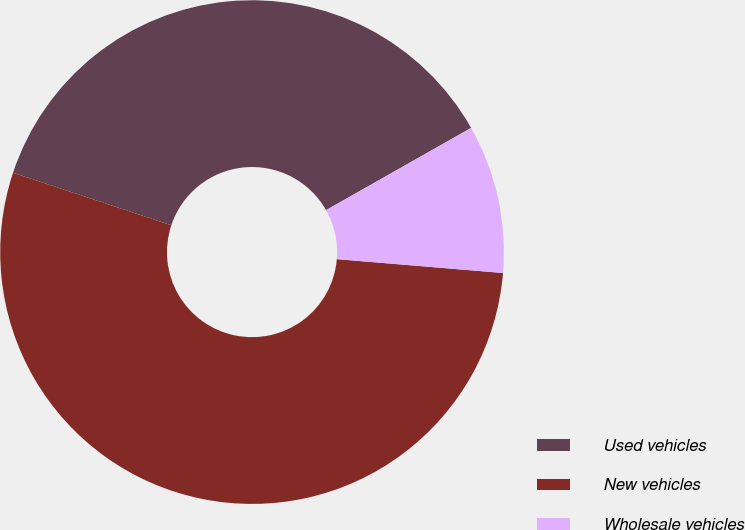Convert chart to OTSL. <chart><loc_0><loc_0><loc_500><loc_500><pie_chart><fcel>Used vehicles<fcel>New vehicles<fcel>Wholesale vehicles<nl><fcel>36.69%<fcel>53.78%<fcel>9.53%<nl></chart> 